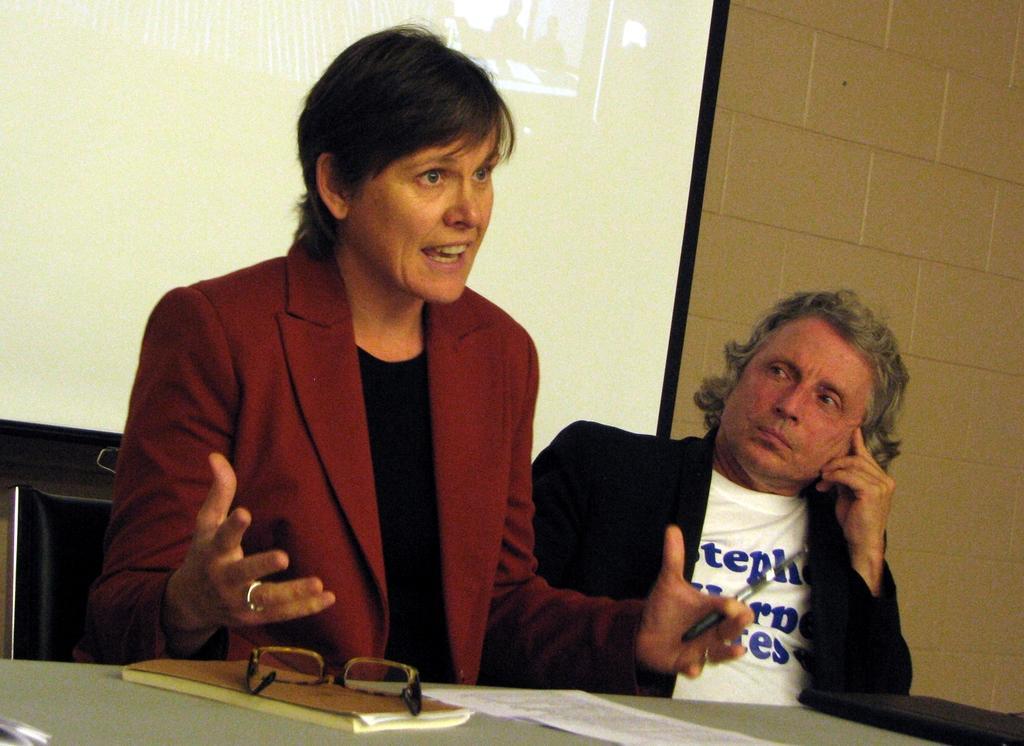Can you describe this image briefly? This is an inside view. Here I can see a woman wearing suit, sitting on a chair and speaking. Beside her I can see a man wearing black color suit, white color t-shirt, sitting and looking at this woman. In front of these people I can see a table on which a book, paper, file and spectacles are placed. In the background, I can see a screen which is attached to the wall. 